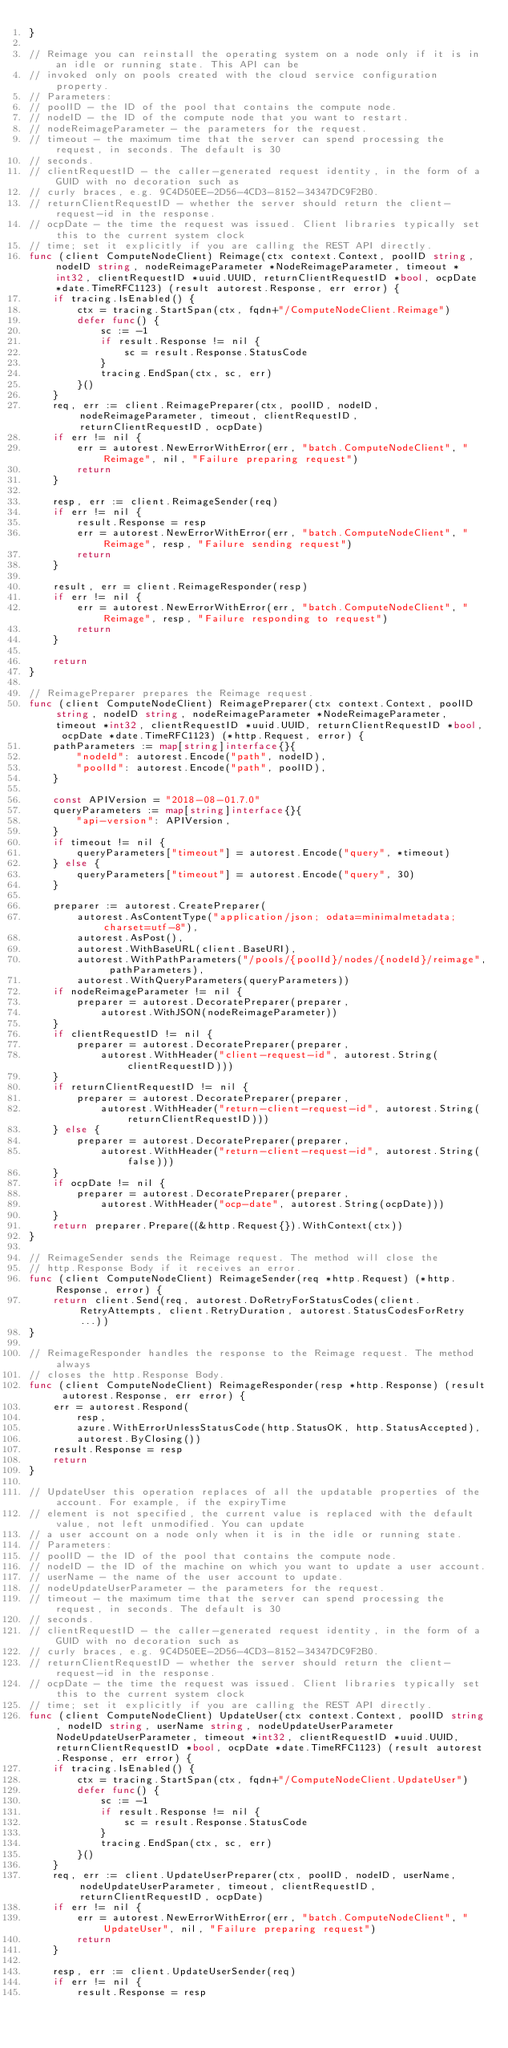<code> <loc_0><loc_0><loc_500><loc_500><_Go_>}

// Reimage you can reinstall the operating system on a node only if it is in an idle or running state. This API can be
// invoked only on pools created with the cloud service configuration property.
// Parameters:
// poolID - the ID of the pool that contains the compute node.
// nodeID - the ID of the compute node that you want to restart.
// nodeReimageParameter - the parameters for the request.
// timeout - the maximum time that the server can spend processing the request, in seconds. The default is 30
// seconds.
// clientRequestID - the caller-generated request identity, in the form of a GUID with no decoration such as
// curly braces, e.g. 9C4D50EE-2D56-4CD3-8152-34347DC9F2B0.
// returnClientRequestID - whether the server should return the client-request-id in the response.
// ocpDate - the time the request was issued. Client libraries typically set this to the current system clock
// time; set it explicitly if you are calling the REST API directly.
func (client ComputeNodeClient) Reimage(ctx context.Context, poolID string, nodeID string, nodeReimageParameter *NodeReimageParameter, timeout *int32, clientRequestID *uuid.UUID, returnClientRequestID *bool, ocpDate *date.TimeRFC1123) (result autorest.Response, err error) {
	if tracing.IsEnabled() {
		ctx = tracing.StartSpan(ctx, fqdn+"/ComputeNodeClient.Reimage")
		defer func() {
			sc := -1
			if result.Response != nil {
				sc = result.Response.StatusCode
			}
			tracing.EndSpan(ctx, sc, err)
		}()
	}
	req, err := client.ReimagePreparer(ctx, poolID, nodeID, nodeReimageParameter, timeout, clientRequestID, returnClientRequestID, ocpDate)
	if err != nil {
		err = autorest.NewErrorWithError(err, "batch.ComputeNodeClient", "Reimage", nil, "Failure preparing request")
		return
	}

	resp, err := client.ReimageSender(req)
	if err != nil {
		result.Response = resp
		err = autorest.NewErrorWithError(err, "batch.ComputeNodeClient", "Reimage", resp, "Failure sending request")
		return
	}

	result, err = client.ReimageResponder(resp)
	if err != nil {
		err = autorest.NewErrorWithError(err, "batch.ComputeNodeClient", "Reimage", resp, "Failure responding to request")
		return
	}

	return
}

// ReimagePreparer prepares the Reimage request.
func (client ComputeNodeClient) ReimagePreparer(ctx context.Context, poolID string, nodeID string, nodeReimageParameter *NodeReimageParameter, timeout *int32, clientRequestID *uuid.UUID, returnClientRequestID *bool, ocpDate *date.TimeRFC1123) (*http.Request, error) {
	pathParameters := map[string]interface{}{
		"nodeId": autorest.Encode("path", nodeID),
		"poolId": autorest.Encode("path", poolID),
	}

	const APIVersion = "2018-08-01.7.0"
	queryParameters := map[string]interface{}{
		"api-version": APIVersion,
	}
	if timeout != nil {
		queryParameters["timeout"] = autorest.Encode("query", *timeout)
	} else {
		queryParameters["timeout"] = autorest.Encode("query", 30)
	}

	preparer := autorest.CreatePreparer(
		autorest.AsContentType("application/json; odata=minimalmetadata; charset=utf-8"),
		autorest.AsPost(),
		autorest.WithBaseURL(client.BaseURI),
		autorest.WithPathParameters("/pools/{poolId}/nodes/{nodeId}/reimage", pathParameters),
		autorest.WithQueryParameters(queryParameters))
	if nodeReimageParameter != nil {
		preparer = autorest.DecoratePreparer(preparer,
			autorest.WithJSON(nodeReimageParameter))
	}
	if clientRequestID != nil {
		preparer = autorest.DecoratePreparer(preparer,
			autorest.WithHeader("client-request-id", autorest.String(clientRequestID)))
	}
	if returnClientRequestID != nil {
		preparer = autorest.DecoratePreparer(preparer,
			autorest.WithHeader("return-client-request-id", autorest.String(returnClientRequestID)))
	} else {
		preparer = autorest.DecoratePreparer(preparer,
			autorest.WithHeader("return-client-request-id", autorest.String(false)))
	}
	if ocpDate != nil {
		preparer = autorest.DecoratePreparer(preparer,
			autorest.WithHeader("ocp-date", autorest.String(ocpDate)))
	}
	return preparer.Prepare((&http.Request{}).WithContext(ctx))
}

// ReimageSender sends the Reimage request. The method will close the
// http.Response Body if it receives an error.
func (client ComputeNodeClient) ReimageSender(req *http.Request) (*http.Response, error) {
	return client.Send(req, autorest.DoRetryForStatusCodes(client.RetryAttempts, client.RetryDuration, autorest.StatusCodesForRetry...))
}

// ReimageResponder handles the response to the Reimage request. The method always
// closes the http.Response Body.
func (client ComputeNodeClient) ReimageResponder(resp *http.Response) (result autorest.Response, err error) {
	err = autorest.Respond(
		resp,
		azure.WithErrorUnlessStatusCode(http.StatusOK, http.StatusAccepted),
		autorest.ByClosing())
	result.Response = resp
	return
}

// UpdateUser this operation replaces of all the updatable properties of the account. For example, if the expiryTime
// element is not specified, the current value is replaced with the default value, not left unmodified. You can update
// a user account on a node only when it is in the idle or running state.
// Parameters:
// poolID - the ID of the pool that contains the compute node.
// nodeID - the ID of the machine on which you want to update a user account.
// userName - the name of the user account to update.
// nodeUpdateUserParameter - the parameters for the request.
// timeout - the maximum time that the server can spend processing the request, in seconds. The default is 30
// seconds.
// clientRequestID - the caller-generated request identity, in the form of a GUID with no decoration such as
// curly braces, e.g. 9C4D50EE-2D56-4CD3-8152-34347DC9F2B0.
// returnClientRequestID - whether the server should return the client-request-id in the response.
// ocpDate - the time the request was issued. Client libraries typically set this to the current system clock
// time; set it explicitly if you are calling the REST API directly.
func (client ComputeNodeClient) UpdateUser(ctx context.Context, poolID string, nodeID string, userName string, nodeUpdateUserParameter NodeUpdateUserParameter, timeout *int32, clientRequestID *uuid.UUID, returnClientRequestID *bool, ocpDate *date.TimeRFC1123) (result autorest.Response, err error) {
	if tracing.IsEnabled() {
		ctx = tracing.StartSpan(ctx, fqdn+"/ComputeNodeClient.UpdateUser")
		defer func() {
			sc := -1
			if result.Response != nil {
				sc = result.Response.StatusCode
			}
			tracing.EndSpan(ctx, sc, err)
		}()
	}
	req, err := client.UpdateUserPreparer(ctx, poolID, nodeID, userName, nodeUpdateUserParameter, timeout, clientRequestID, returnClientRequestID, ocpDate)
	if err != nil {
		err = autorest.NewErrorWithError(err, "batch.ComputeNodeClient", "UpdateUser", nil, "Failure preparing request")
		return
	}

	resp, err := client.UpdateUserSender(req)
	if err != nil {
		result.Response = resp</code> 